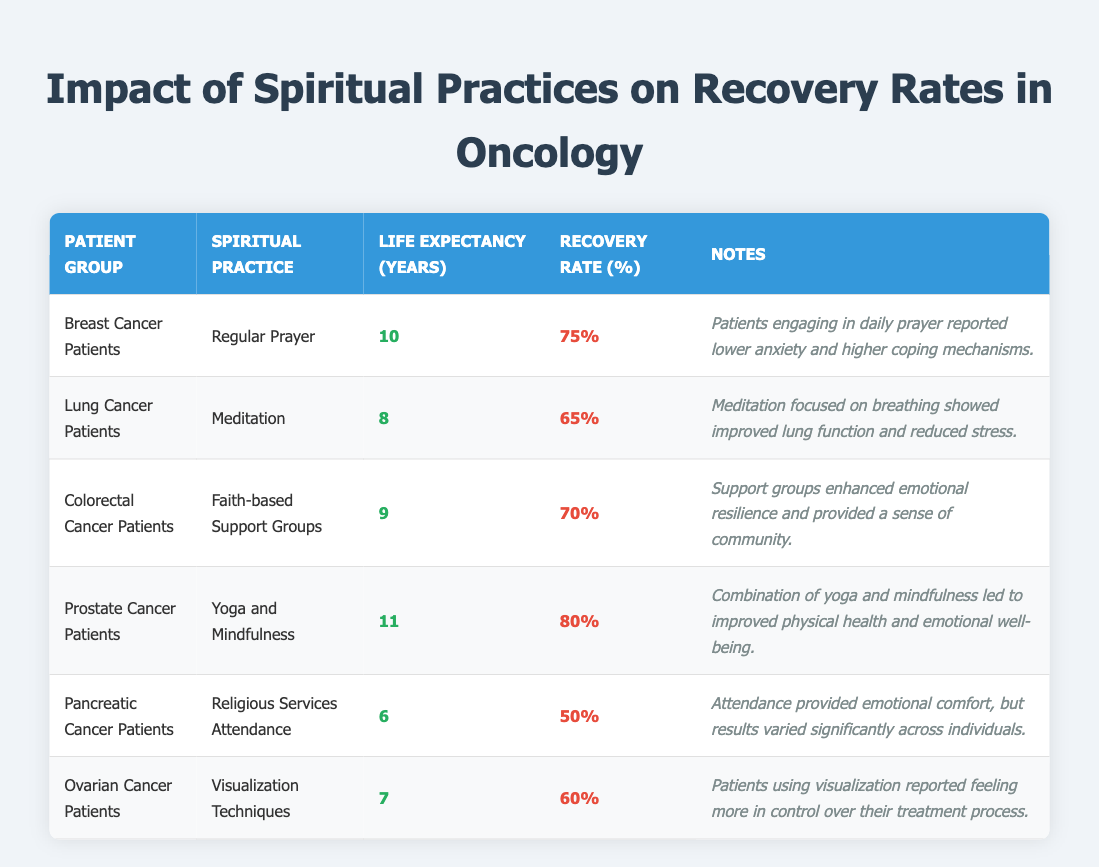What is the life expectancy for Breast Cancer Patients engaging in Regular Prayer? According to the table, Breast Cancer Patients who engage in Regular Prayer have a life expectancy of 10 years.
Answer: 10 years What is the recovery rate for Lung Cancer Patients who practice Meditation? The table shows that Lung Cancer Patients practicing Meditation have a recovery rate of 65%.
Answer: 65% Is the recovery rate for Prostate Cancer Patients higher than that for Ovarian Cancer Patients? The recovery rate for Prostate Cancer Patients is 80%, while for Ovarian Cancer Patients, it is 60%. Since 80% is greater than 60%, the statement is true.
Answer: Yes Which spiritual practice had the lowest life expectancy according to the table? Pancreatic Cancer Patients who attend Religious Services have the lowest life expectancy of 6 years among the listed practices.
Answer: Religious Services Attendance What is the average life expectancy of the patient groups listed? Adding up the life expectancies: 10 + 8 + 9 + 11 + 6 + 7 = 51. There are 6 patient groups, so the average is 51 / 6 = 8.5 years.
Answer: 8.5 years Do Faith-based Support Groups have a higher recovery rate than Visualization Techniques? Faith-based Support Groups have a recovery rate of 70%, while Visualization Techniques have a recovery rate of 60%. Since 70% is greater than 60%, the statement is true.
Answer: Yes What percentage of recovery do Colorectal Cancer Patients achieve through Faith-based Support Groups? The table indicates that Colorectal Cancer Patients achieve a recovery rate of 70% by participating in Faith-based Support Groups.
Answer: 70% What was the life expectancy difference between Prostate Cancer Patients and Pancreatic Cancer Patients? Prostate Cancer Patients have a life expectancy of 11 years, while Pancreatic Cancer Patients have 6 years. The difference is 11 - 6 = 5 years.
Answer: 5 years What is the correlation between spiritual practices and emotional resilience based on the data? The notes in the table suggest that various spiritual practices, such as Faith-based Support Groups and Regular Prayer, enhanced emotional resilience. Therefore, a positive correlation exists, as practices with supportive elements generally lead to better emotional outcomes.
Answer: Positive correlation 